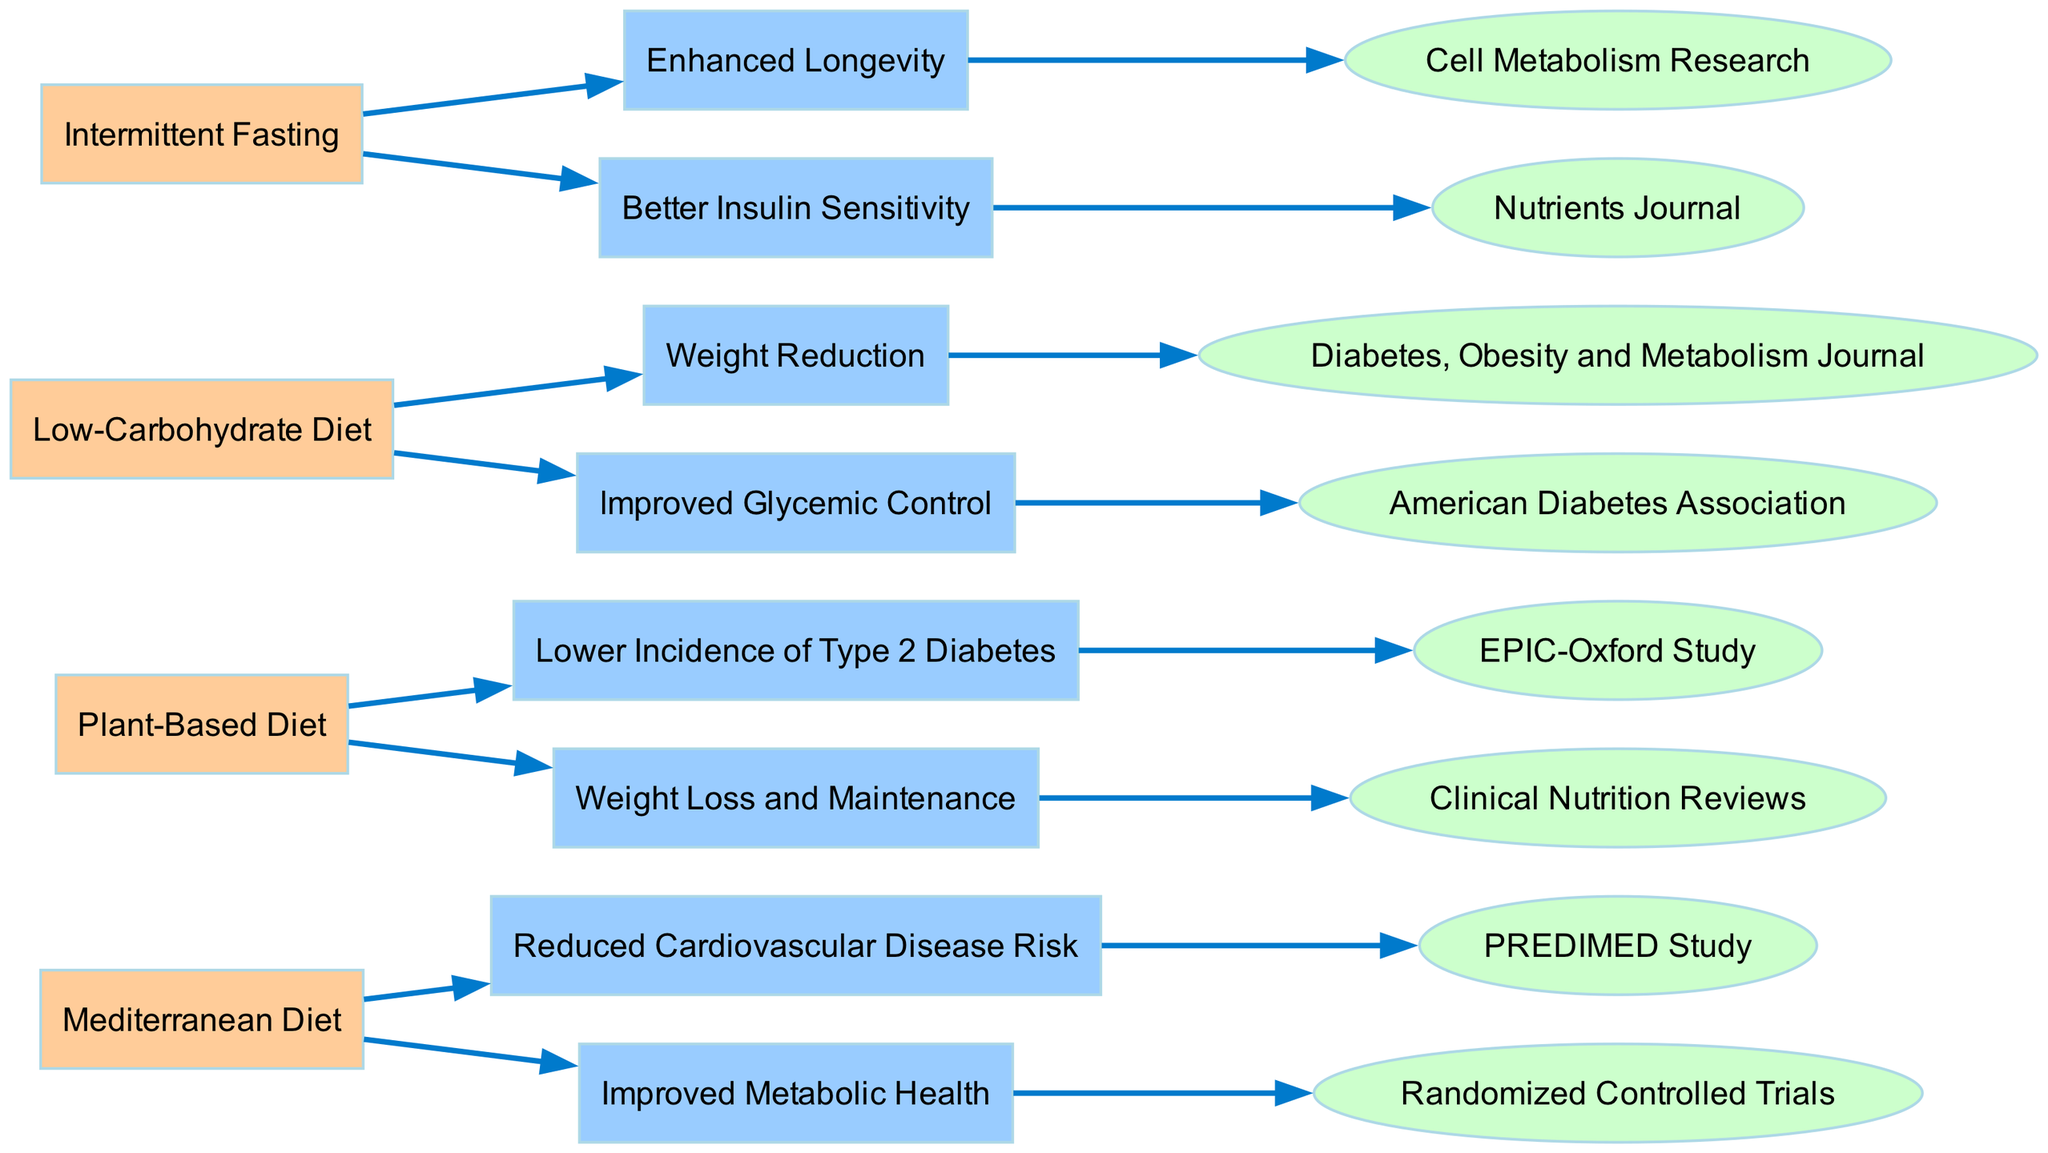What dietary intervention is linked to reduced cardiovascular disease risk? The diagram indicates that the "Mediterranean Diet" intervention is connected to the outcome "Reduced Cardiovascular Disease Risk", showing a direct relationship.
Answer: Mediterranean Diet How many total interventions are represented in the diagram? By counting the number of interventions listed, which are "Mediterranean Diet", "Plant-Based Diet", "Low-Carbohydrate Diet", and "Intermittent Fasting", we find a total of four interventions.
Answer: 4 What is one outcome of the Plant-Based Diet according to the diagram? The diagram shows that the "Plant-Based Diet" is associated with several outcomes, one of which is "Lower Incidence of Type 2 Diabetes".
Answer: Lower Incidence of Type 2 Diabetes Which intervention leads to improved glycemic control? The "Low-Carbohydrate Diet" intervention is shown to lead to the outcome "Improved Glycemic Control", establishing a direct connection.
Answer: Low-Carbohydrate Diet Name a specific study related to the evidence for intermittent fasting. The diagram cites "Cell Metabolism Research" as the evidence for the outcome "Enhanced Longevity" related to the "Intermittent Fasting" intervention.
Answer: Cell Metabolism Research Which intervention has the outcome of better insulin sensitivity? The "Intermittent Fasting" intervention is directly connected to the outcome "Better Insulin Sensitivity" in the diagram, indicating a relationship between the two.
Answer: Intermittent Fasting What is the evidence supporting the weight loss outcome of the Plant-Based Diet? The diagram provides "Clinical Nutrition Reviews" as the evidence supporting the outcome "Weight Loss and Maintenance" associated with the "Plant-Based Diet".
Answer: Clinical Nutrition Reviews Are there more outcomes linked to the Mediterranean Diet or the Low-Carbohydrate Diet? Both the "Mediterranean Diet" and "Low-Carbohydrate Diet" interventions are linked to two outcomes each, making the counts equal when examined from the diagram.
Answer: Equal What type of diagram is used here to represent the data? The structure displayed in the dataset is identified as a "Sankey Diagram," which is used for visualizing flow and relationships.
Answer: Sankey Diagram 